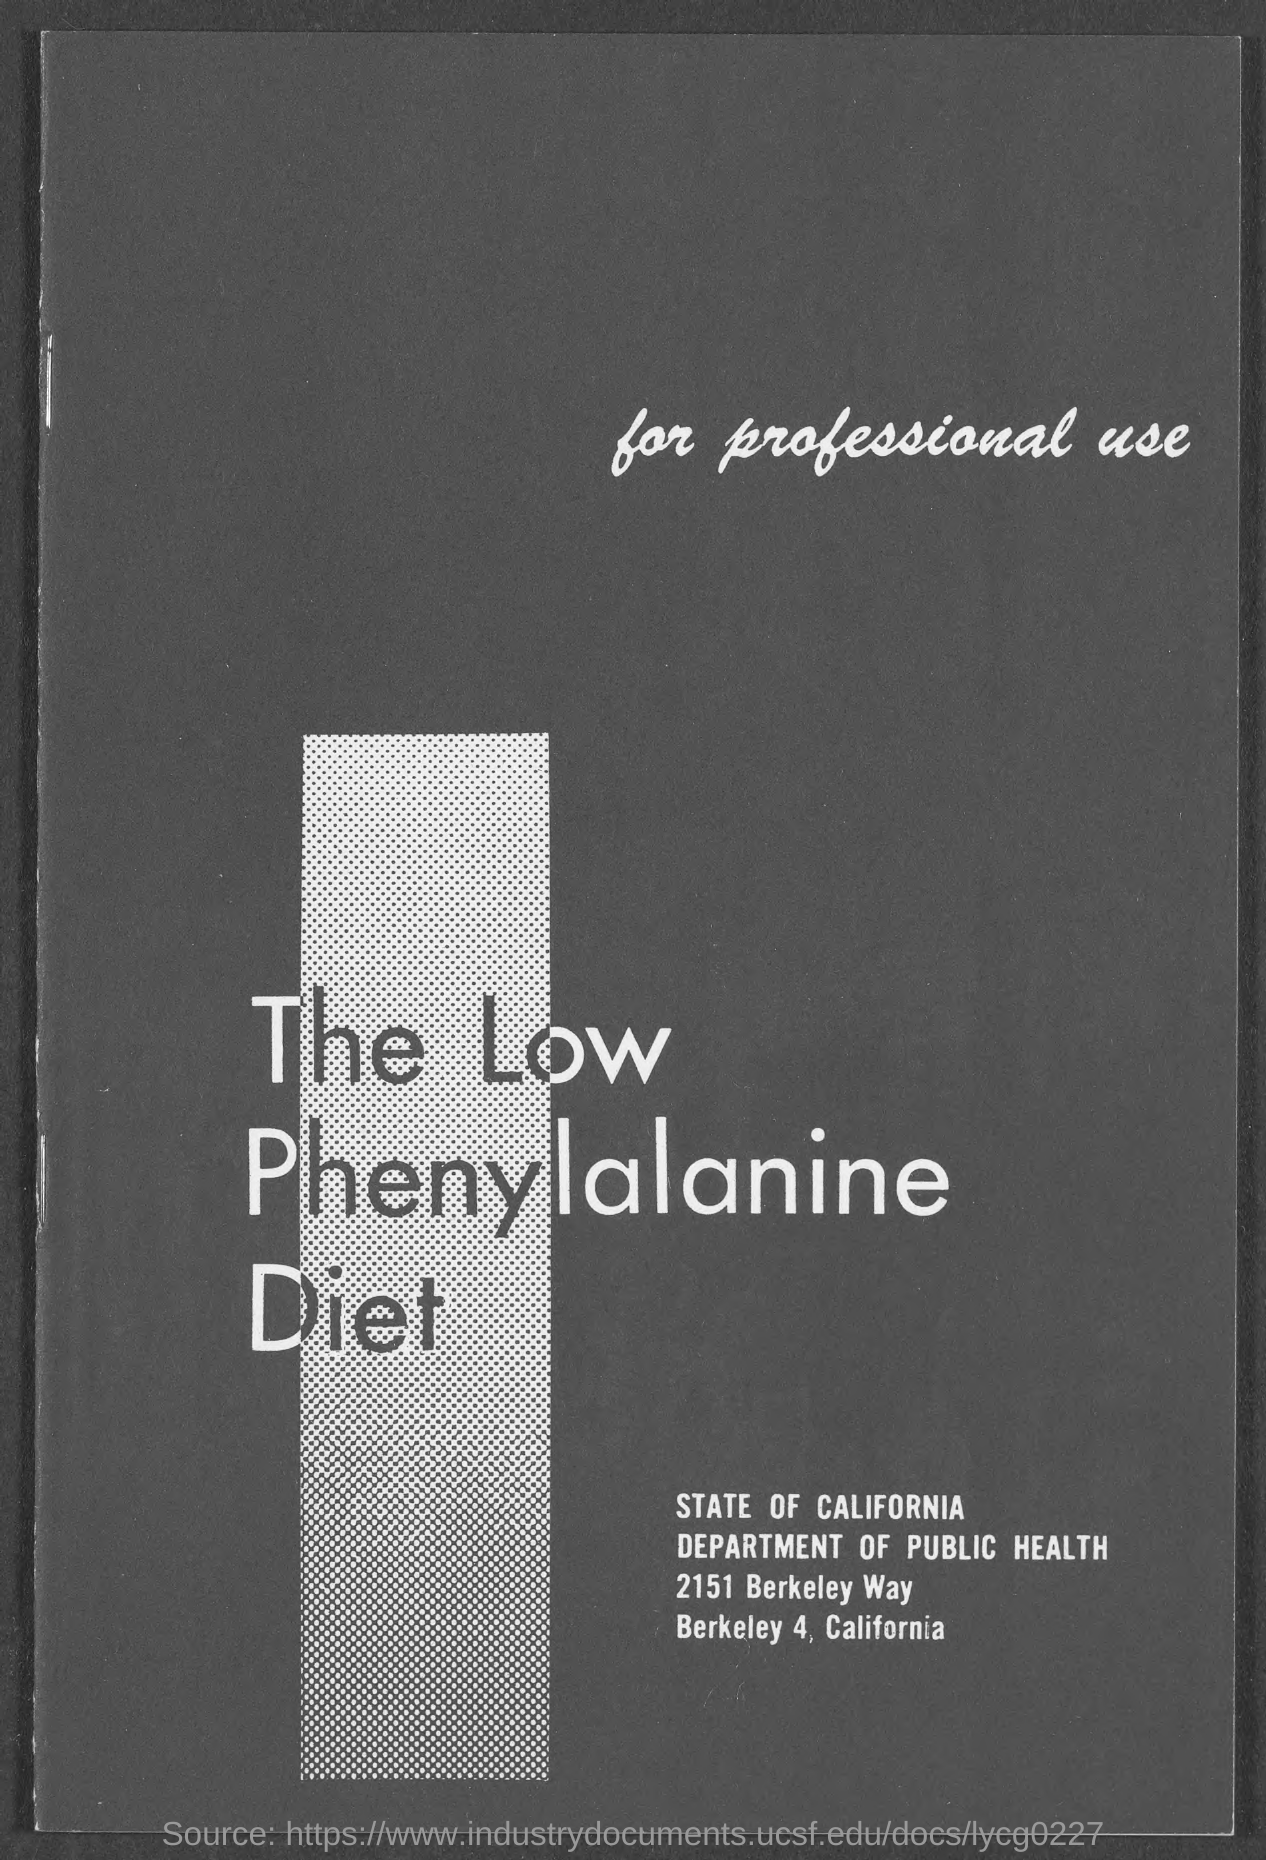What is the title?
Offer a terse response. The low phenylalanine diet. What is the department name mentioned?
Ensure brevity in your answer.  DEPARTMENT OF PUBLIC HEALTH. 